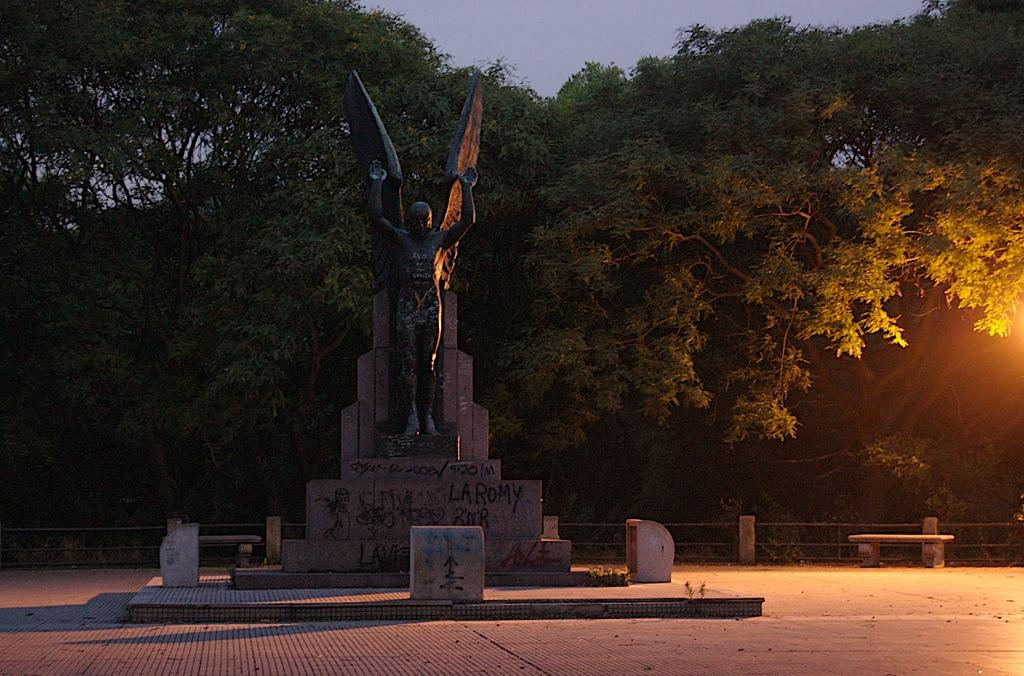What is the main subject of the image? There is a statue in the image. Where is the statue located? The statue is on a wall. What can be seen in the background of the image? There are trees in the background of the image. What is in front of the trees? There is a metal fence in front of the trees. What is another object present in the image? There is a bench in the image. How many legs does the powder have in the image? There is no powder present in the image, so it is not possible to determine the number of legs it might have. 